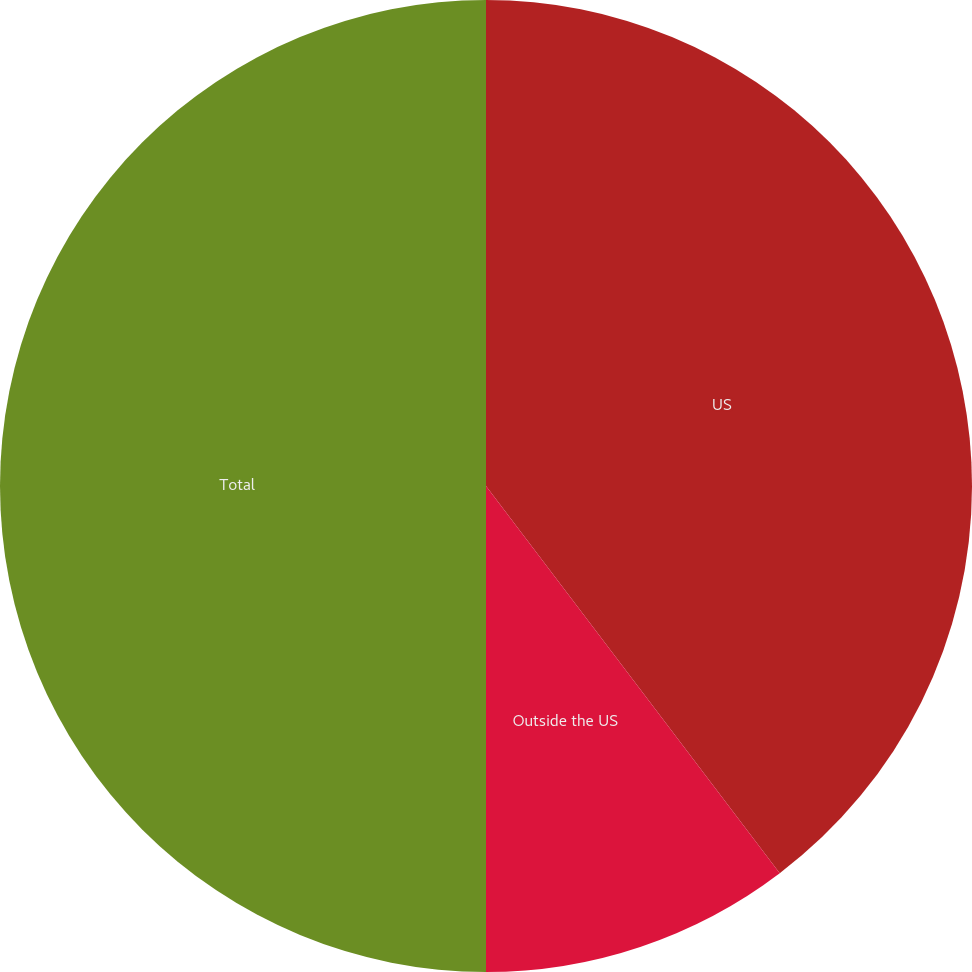Convert chart to OTSL. <chart><loc_0><loc_0><loc_500><loc_500><pie_chart><fcel>US<fcel>Outside the US<fcel>Total<nl><fcel>39.67%<fcel>10.33%<fcel>50.0%<nl></chart> 